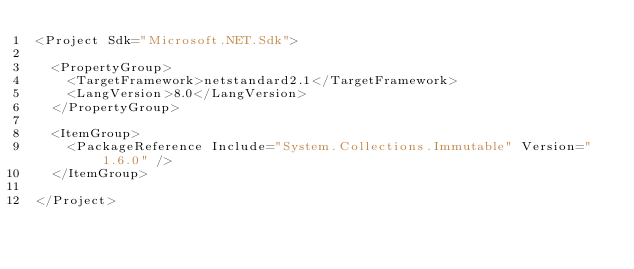<code> <loc_0><loc_0><loc_500><loc_500><_XML_><Project Sdk="Microsoft.NET.Sdk">

  <PropertyGroup>
    <TargetFramework>netstandard2.1</TargetFramework>
    <LangVersion>8.0</LangVersion>
  </PropertyGroup>

  <ItemGroup>
    <PackageReference Include="System.Collections.Immutable" Version="1.6.0" />
  </ItemGroup>

</Project>
</code> 